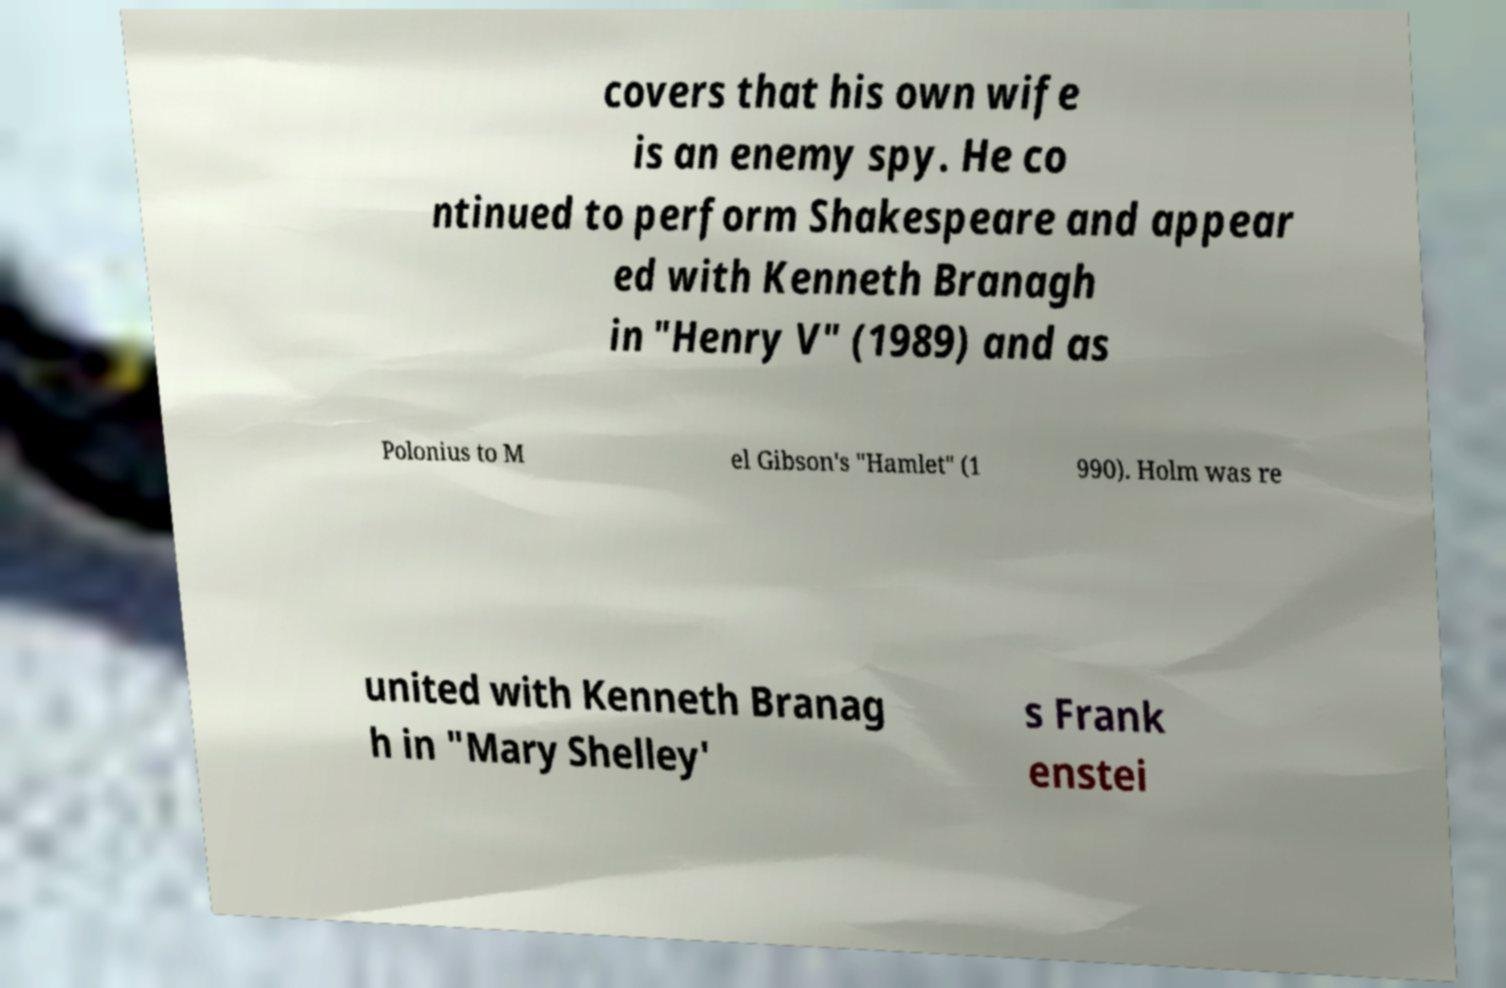Please identify and transcribe the text found in this image. covers that his own wife is an enemy spy. He co ntinued to perform Shakespeare and appear ed with Kenneth Branagh in "Henry V" (1989) and as Polonius to M el Gibson's "Hamlet" (1 990). Holm was re united with Kenneth Branag h in "Mary Shelley' s Frank enstei 